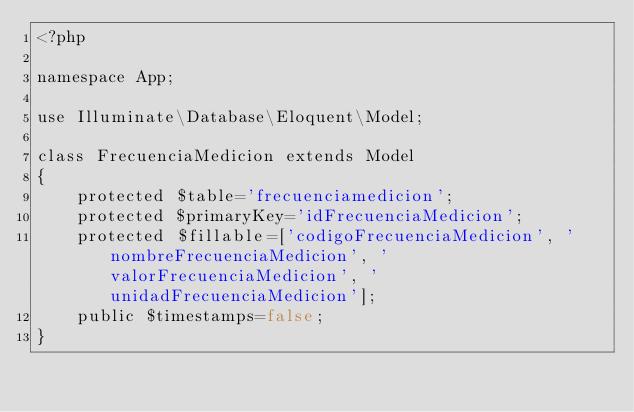Convert code to text. <code><loc_0><loc_0><loc_500><loc_500><_PHP_><?php

namespace App;

use Illuminate\Database\Eloquent\Model;

class FrecuenciaMedicion extends Model
{
    protected $table='frecuenciamedicion';
    protected $primaryKey='idFrecuenciaMedicion';
    protected $fillable=['codigoFrecuenciaMedicion', 'nombreFrecuenciaMedicion', 'valorFrecuenciaMedicion', 'unidadFrecuenciaMedicion'];
    public $timestamps=false;
}
</code> 